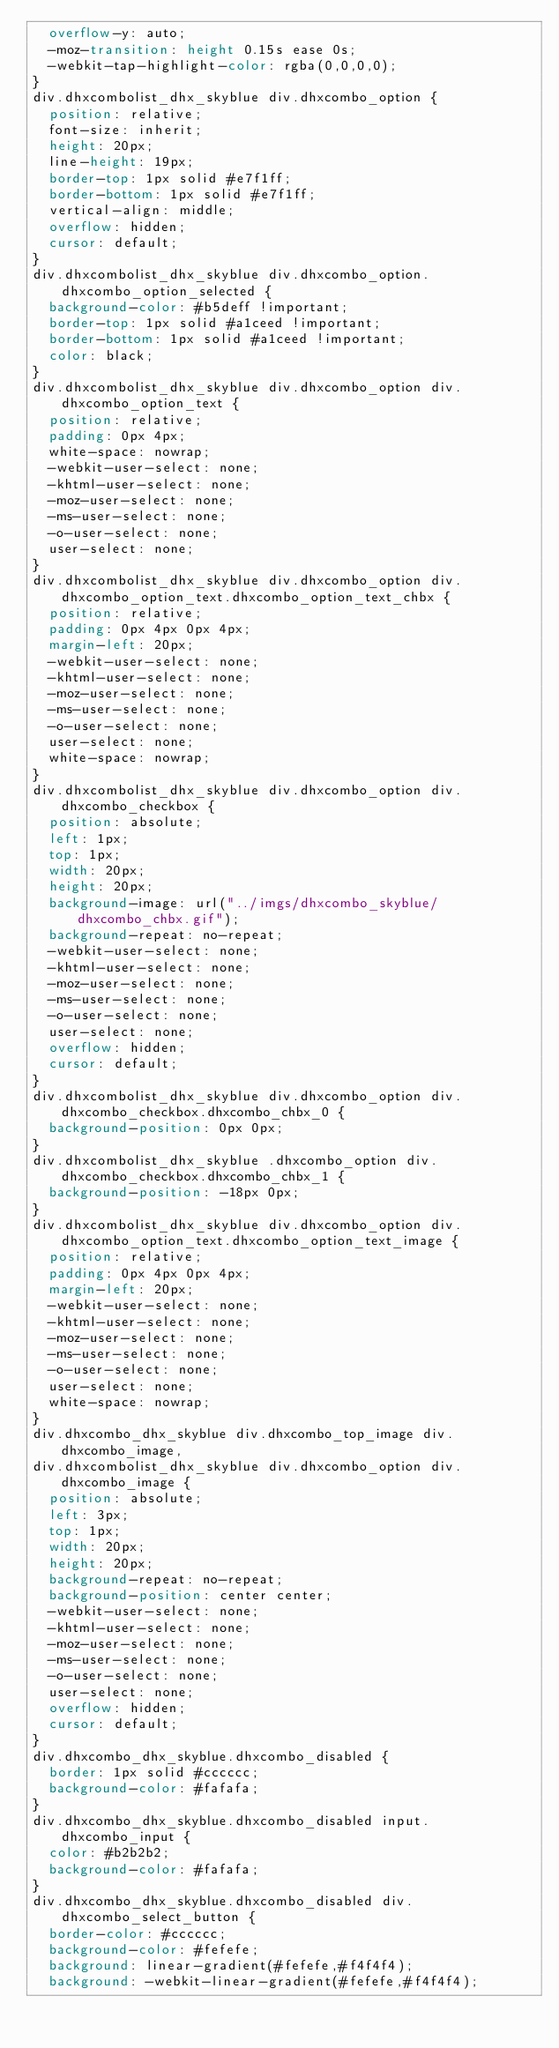Convert code to text. <code><loc_0><loc_0><loc_500><loc_500><_CSS_>	overflow-y: auto;
	-moz-transition: height 0.15s ease 0s;
	-webkit-tap-highlight-color: rgba(0,0,0,0);
}
div.dhxcombolist_dhx_skyblue div.dhxcombo_option {
	position: relative;
	font-size: inherit;
	height: 20px;
	line-height: 19px;
	border-top: 1px solid #e7f1ff;
	border-bottom: 1px solid #e7f1ff;
	vertical-align: middle;
	overflow: hidden;
	cursor: default;
}
div.dhxcombolist_dhx_skyblue div.dhxcombo_option.dhxcombo_option_selected {
	background-color: #b5deff !important;
	border-top: 1px solid #a1ceed !important;
	border-bottom: 1px solid #a1ceed !important;
	color: black;
}
div.dhxcombolist_dhx_skyblue div.dhxcombo_option div.dhxcombo_option_text {
	position: relative;
	padding: 0px 4px;
	white-space: nowrap;
	-webkit-user-select: none;
	-khtml-user-select: none;
	-moz-user-select: none;
	-ms-user-select: none;
	-o-user-select: none;
	user-select: none;
}
div.dhxcombolist_dhx_skyblue div.dhxcombo_option div.dhxcombo_option_text.dhxcombo_option_text_chbx {
	position: relative;
	padding: 0px 4px 0px 4px;
	margin-left: 20px;
	-webkit-user-select: none;
	-khtml-user-select: none;
	-moz-user-select: none;
	-ms-user-select: none;
	-o-user-select: none;
	user-select: none;
	white-space: nowrap;
}
div.dhxcombolist_dhx_skyblue div.dhxcombo_option div.dhxcombo_checkbox {
	position: absolute;
	left: 1px;
	top: 1px;
	width: 20px;
	height: 20px;
	background-image: url("../imgs/dhxcombo_skyblue/dhxcombo_chbx.gif");
	background-repeat: no-repeat;
	-webkit-user-select: none;
	-khtml-user-select: none;
	-moz-user-select: none;
	-ms-user-select: none;
	-o-user-select: none;
	user-select: none;
	overflow: hidden;
	cursor: default;
}
div.dhxcombolist_dhx_skyblue div.dhxcombo_option div.dhxcombo_checkbox.dhxcombo_chbx_0 {
	background-position: 0px 0px;
}
div.dhxcombolist_dhx_skyblue .dhxcombo_option div.dhxcombo_checkbox.dhxcombo_chbx_1 {
	background-position: -18px 0px;
}
div.dhxcombolist_dhx_skyblue div.dhxcombo_option div.dhxcombo_option_text.dhxcombo_option_text_image {
	position: relative;
	padding: 0px 4px 0px 4px;
	margin-left: 20px;
	-webkit-user-select: none;
	-khtml-user-select: none;
	-moz-user-select: none;
	-ms-user-select: none;
	-o-user-select: none;
	user-select: none;
	white-space: nowrap;
}
div.dhxcombo_dhx_skyblue div.dhxcombo_top_image div.dhxcombo_image,
div.dhxcombolist_dhx_skyblue div.dhxcombo_option div.dhxcombo_image {
	position: absolute;
	left: 3px;
	top: 1px;
	width: 20px;
	height: 20px;
	background-repeat: no-repeat;
	background-position: center center;
	-webkit-user-select: none;
	-khtml-user-select: none;
	-moz-user-select: none;
	-ms-user-select: none;
	-o-user-select: none;
	user-select: none;
	overflow: hidden;
	cursor: default;
}
div.dhxcombo_dhx_skyblue.dhxcombo_disabled {
	border: 1px solid #cccccc;
	background-color: #fafafa;
}
div.dhxcombo_dhx_skyblue.dhxcombo_disabled input.dhxcombo_input {
	color: #b2b2b2;
	background-color: #fafafa;
}
div.dhxcombo_dhx_skyblue.dhxcombo_disabled div.dhxcombo_select_button {
	border-color: #cccccc;
	background-color: #fefefe;
	background: linear-gradient(#fefefe,#f4f4f4);
	background: -webkit-linear-gradient(#fefefe,#f4f4f4);</code> 